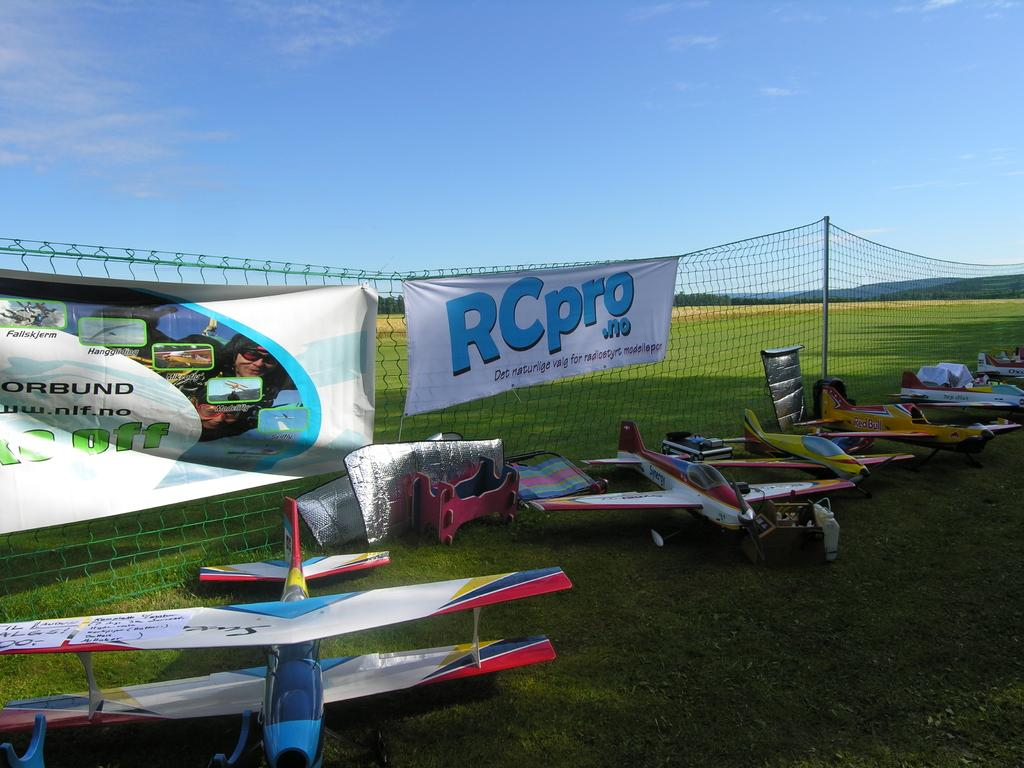<image>
Summarize the visual content of the image. Remote control airplanes sit in front of a banner for RCpro.no 